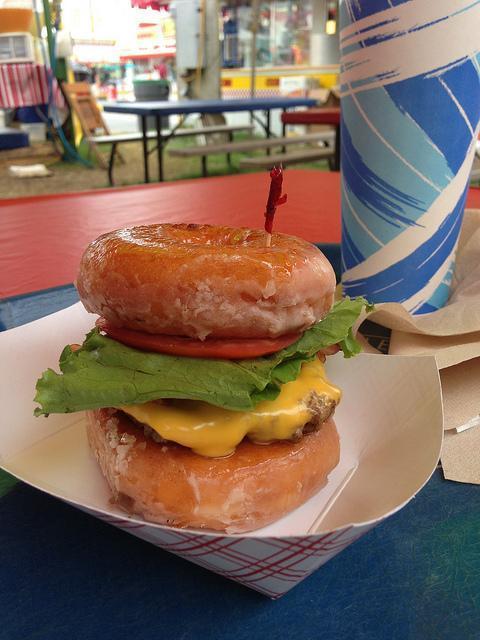Is this affirmation: "The donut is next to the bowl." correct?
Answer yes or no. No. Is the given caption "The donut is in the bowl." fitting for the image?
Answer yes or no. Yes. 